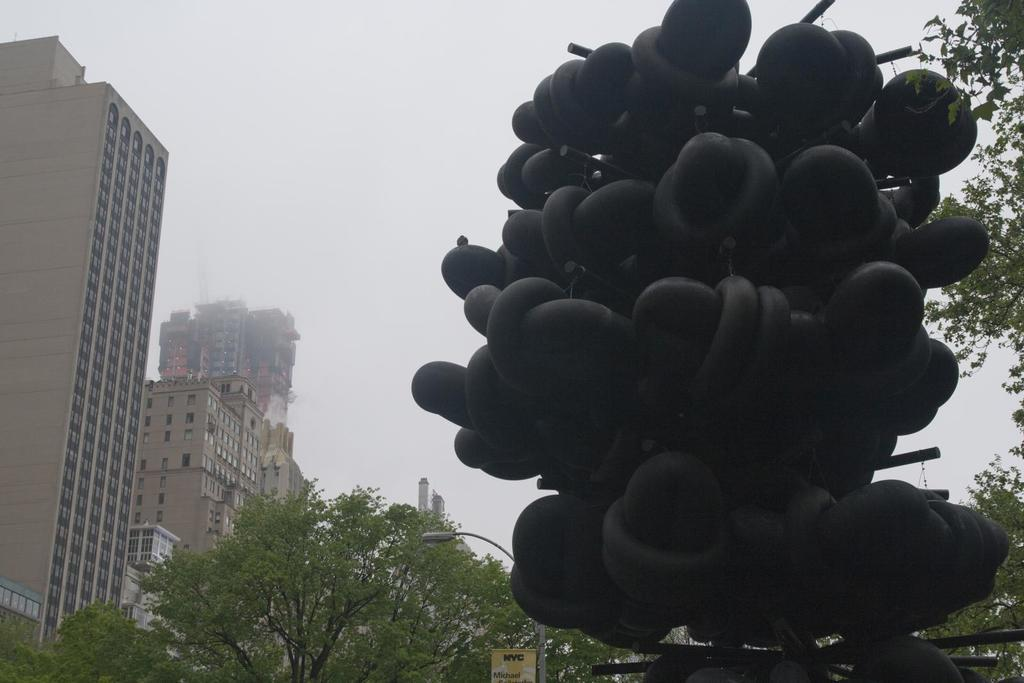What is the main structure in the front of the image? There is a black color structure in the front of the image. What can be seen behind the structure? There are trees behind the structure. What type of building is visible in the image? There is a brown color building with many windows in the image. What is visible at the top of the image? The sky is visible at the top of the image. Can you tell me how many strangers are walking towards the north in the image? There are no strangers or any indication of direction in the image. Is there any evidence of space travel in the image? There is no evidence of space travel or any space-related objects in the image. 